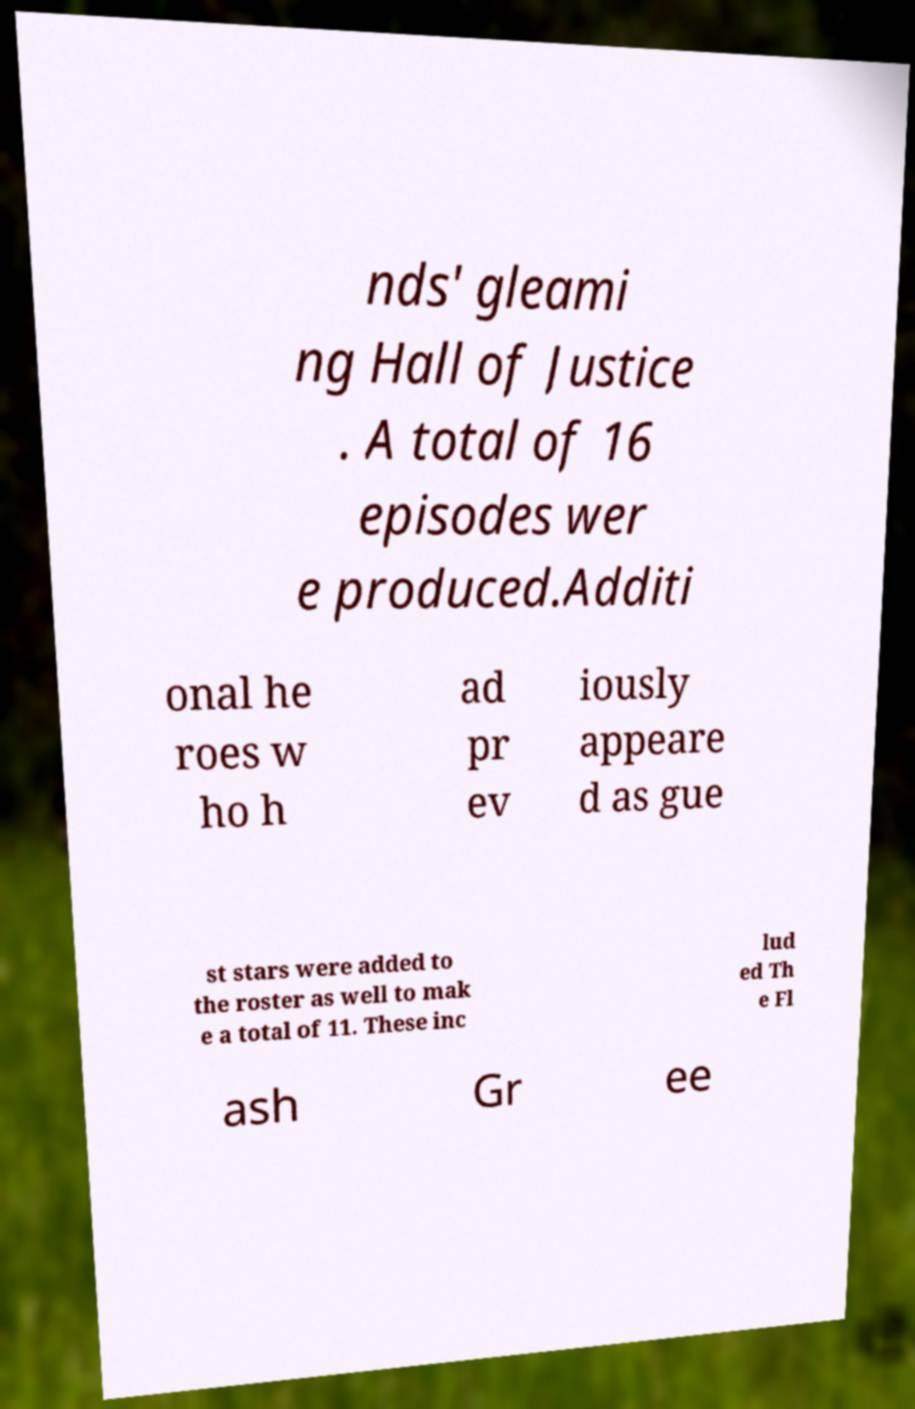Could you assist in decoding the text presented in this image and type it out clearly? nds' gleami ng Hall of Justice . A total of 16 episodes wer e produced.Additi onal he roes w ho h ad pr ev iously appeare d as gue st stars were added to the roster as well to mak e a total of 11. These inc lud ed Th e Fl ash Gr ee 